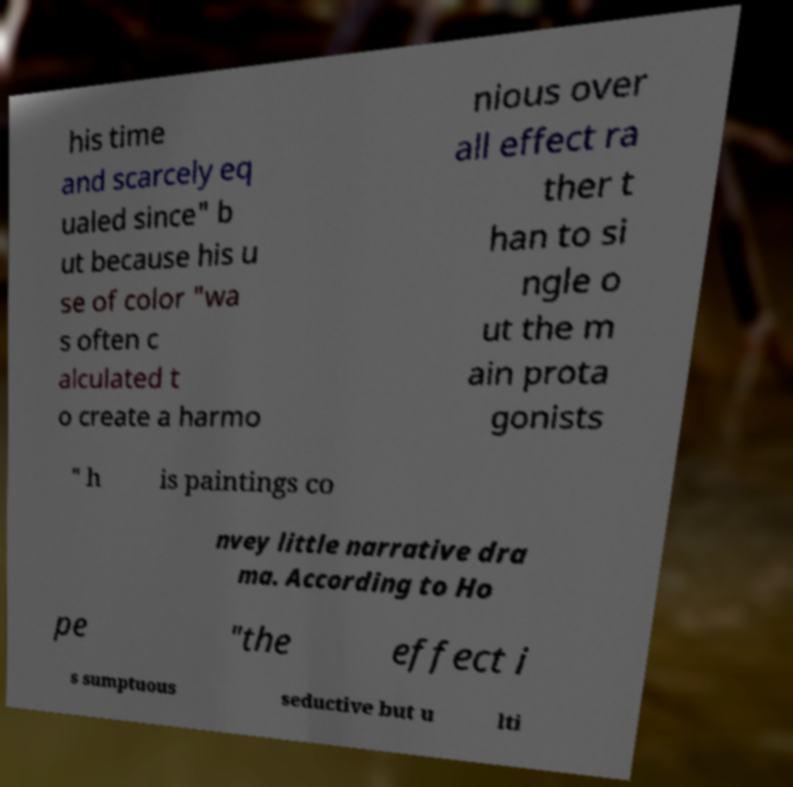Could you extract and type out the text from this image? his time and scarcely eq ualed since" b ut because his u se of color "wa s often c alculated t o create a harmo nious over all effect ra ther t han to si ngle o ut the m ain prota gonists " h is paintings co nvey little narrative dra ma. According to Ho pe "the effect i s sumptuous seductive but u lti 